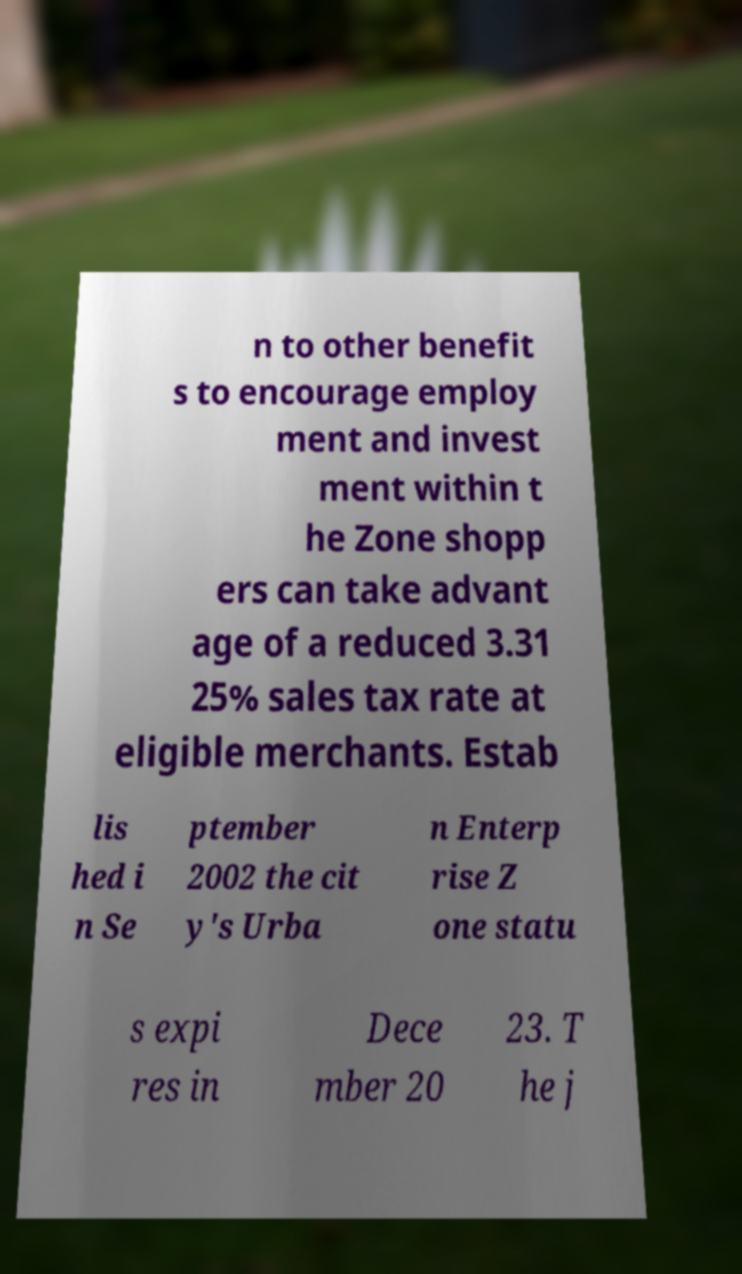I need the written content from this picture converted into text. Can you do that? n to other benefit s to encourage employ ment and invest ment within t he Zone shopp ers can take advant age of a reduced 3.31 25% sales tax rate at eligible merchants. Estab lis hed i n Se ptember 2002 the cit y's Urba n Enterp rise Z one statu s expi res in Dece mber 20 23. T he j 